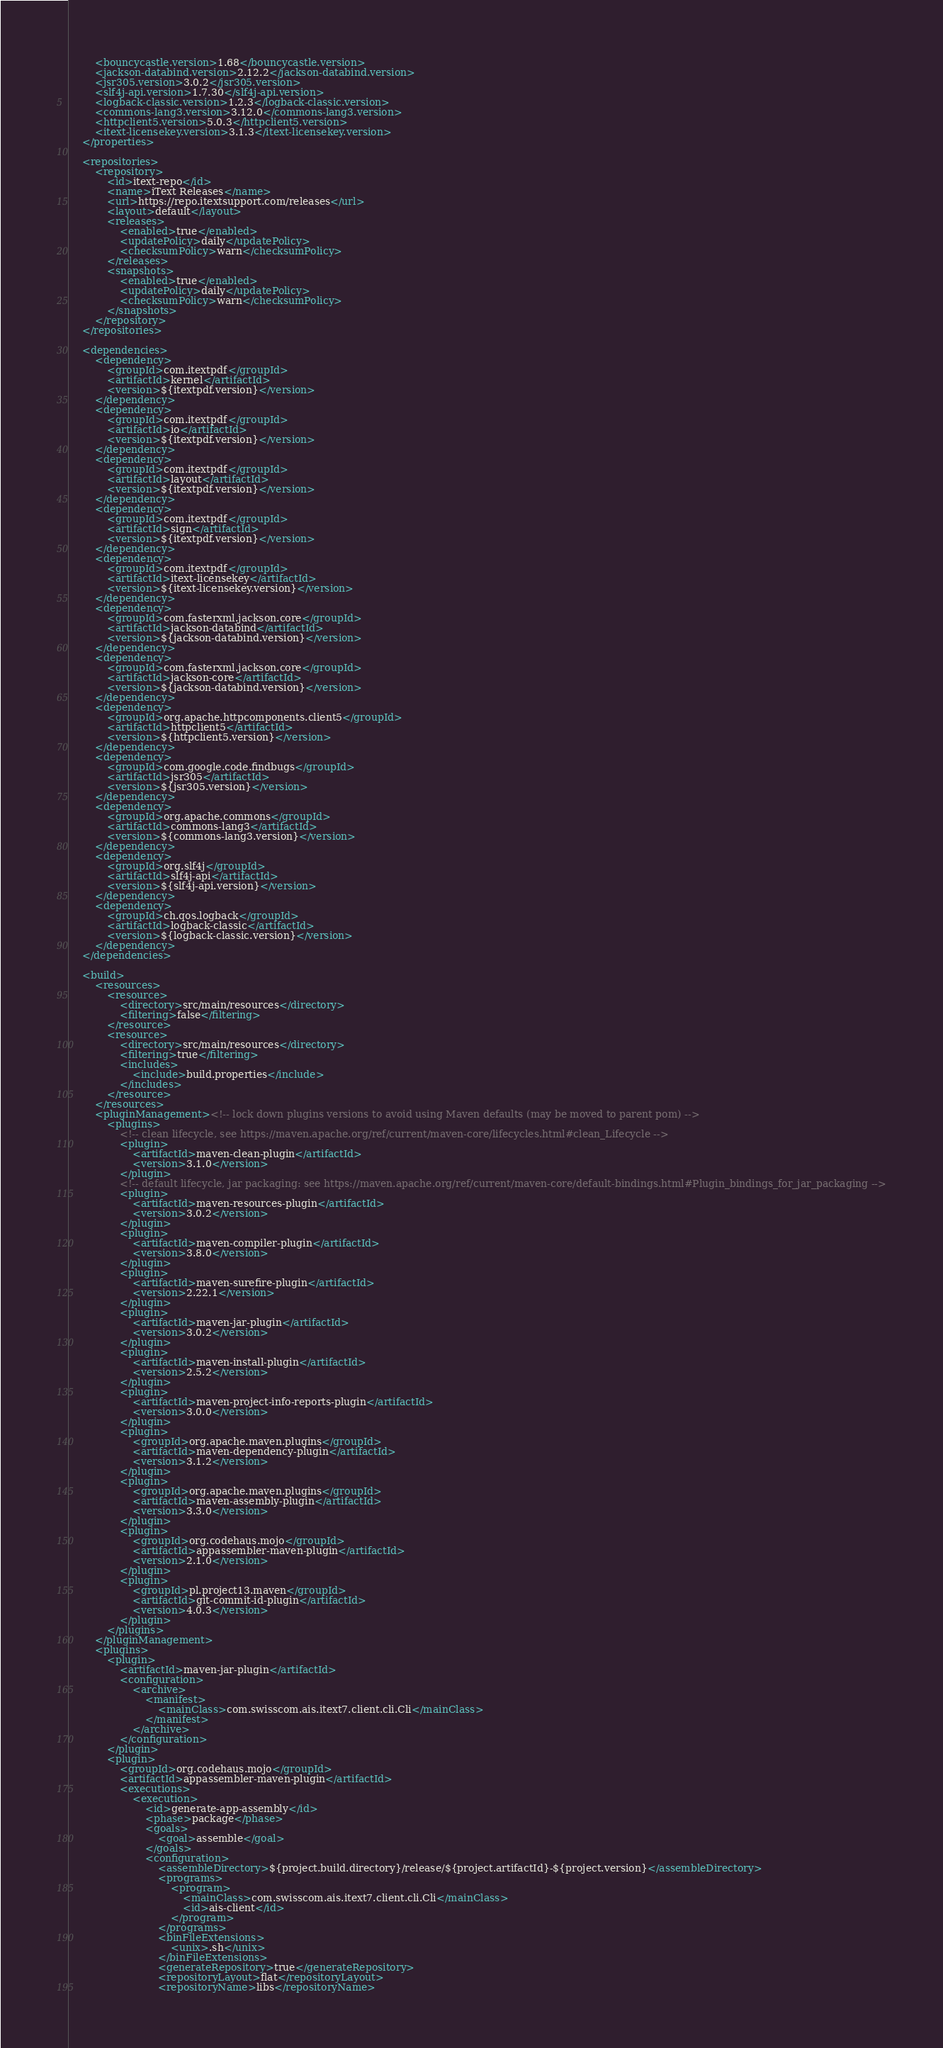<code> <loc_0><loc_0><loc_500><loc_500><_XML_>        <bouncycastle.version>1.68</bouncycastle.version>
        <jackson-databind.version>2.12.2</jackson-databind.version>
        <jsr305.version>3.0.2</jsr305.version>
        <slf4j-api.version>1.7.30</slf4j-api.version>
        <logback-classic.version>1.2.3</logback-classic.version>
        <commons-lang3.version>3.12.0</commons-lang3.version>
        <httpclient5.version>5.0.3</httpclient5.version>
        <itext-licensekey.version>3.1.3</itext-licensekey.version>
    </properties>

    <repositories>
        <repository>
            <id>itext-repo</id>
            <name>iText Releases</name>
            <url>https://repo.itextsupport.com/releases</url>
            <layout>default</layout>
            <releases>
                <enabled>true</enabled>
                <updatePolicy>daily</updatePolicy>
                <checksumPolicy>warn</checksumPolicy>
            </releases>
            <snapshots>
                <enabled>true</enabled>
                <updatePolicy>daily</updatePolicy>
                <checksumPolicy>warn</checksumPolicy>
            </snapshots>
        </repository>
    </repositories>

    <dependencies>
        <dependency>
            <groupId>com.itextpdf</groupId>
            <artifactId>kernel</artifactId>
            <version>${itextpdf.version}</version>
        </dependency>
        <dependency>
            <groupId>com.itextpdf</groupId>
            <artifactId>io</artifactId>
            <version>${itextpdf.version}</version>
        </dependency>
        <dependency>
            <groupId>com.itextpdf</groupId>
            <artifactId>layout</artifactId>
            <version>${itextpdf.version}</version>
        </dependency>
        <dependency>
            <groupId>com.itextpdf</groupId>
            <artifactId>sign</artifactId>
            <version>${itextpdf.version}</version>
        </dependency>
        <dependency>
            <groupId>com.itextpdf</groupId>
            <artifactId>itext-licensekey</artifactId>
            <version>${itext-licensekey.version}</version>
        </dependency>
        <dependency>
            <groupId>com.fasterxml.jackson.core</groupId>
            <artifactId>jackson-databind</artifactId>
            <version>${jackson-databind.version}</version>
        </dependency>
        <dependency>
            <groupId>com.fasterxml.jackson.core</groupId>
            <artifactId>jackson-core</artifactId>
            <version>${jackson-databind.version}</version>
        </dependency>
        <dependency>
            <groupId>org.apache.httpcomponents.client5</groupId>
            <artifactId>httpclient5</artifactId>
            <version>${httpclient5.version}</version>
        </dependency>
        <dependency>
            <groupId>com.google.code.findbugs</groupId>
            <artifactId>jsr305</artifactId>
            <version>${jsr305.version}</version>
        </dependency>
        <dependency>
            <groupId>org.apache.commons</groupId>
            <artifactId>commons-lang3</artifactId>
            <version>${commons-lang3.version}</version>
        </dependency>
        <dependency>
            <groupId>org.slf4j</groupId>
            <artifactId>slf4j-api</artifactId>
            <version>${slf4j-api.version}</version>
        </dependency>
        <dependency>
            <groupId>ch.qos.logback</groupId>
            <artifactId>logback-classic</artifactId>
            <version>${logback-classic.version}</version>
        </dependency>
    </dependencies>

    <build>
        <resources>
            <resource>
                <directory>src/main/resources</directory>
                <filtering>false</filtering>
            </resource>
            <resource>
                <directory>src/main/resources</directory>
                <filtering>true</filtering>
                <includes>
                    <include>build.properties</include>
                </includes>
            </resource>
        </resources>
        <pluginManagement><!-- lock down plugins versions to avoid using Maven defaults (may be moved to parent pom) -->
            <plugins>
                <!-- clean lifecycle, see https://maven.apache.org/ref/current/maven-core/lifecycles.html#clean_Lifecycle -->
                <plugin>
                    <artifactId>maven-clean-plugin</artifactId>
                    <version>3.1.0</version>
                </plugin>
                <!-- default lifecycle, jar packaging: see https://maven.apache.org/ref/current/maven-core/default-bindings.html#Plugin_bindings_for_jar_packaging -->
                <plugin>
                    <artifactId>maven-resources-plugin</artifactId>
                    <version>3.0.2</version>
                </plugin>
                <plugin>
                    <artifactId>maven-compiler-plugin</artifactId>
                    <version>3.8.0</version>
                </plugin>
                <plugin>
                    <artifactId>maven-surefire-plugin</artifactId>
                    <version>2.22.1</version>
                </plugin>
                <plugin>
                    <artifactId>maven-jar-plugin</artifactId>
                    <version>3.0.2</version>
                </plugin>
                <plugin>
                    <artifactId>maven-install-plugin</artifactId>
                    <version>2.5.2</version>
                </plugin>
                <plugin>
                    <artifactId>maven-project-info-reports-plugin</artifactId>
                    <version>3.0.0</version>
                </plugin>
                <plugin>
                    <groupId>org.apache.maven.plugins</groupId>
                    <artifactId>maven-dependency-plugin</artifactId>
                    <version>3.1.2</version>
                </plugin>
                <plugin>
                    <groupId>org.apache.maven.plugins</groupId>
                    <artifactId>maven-assembly-plugin</artifactId>
                    <version>3.3.0</version>
                </plugin>
                <plugin>
                    <groupId>org.codehaus.mojo</groupId>
                    <artifactId>appassembler-maven-plugin</artifactId>
                    <version>2.1.0</version>
                </plugin>
                <plugin>
                    <groupId>pl.project13.maven</groupId>
                    <artifactId>git-commit-id-plugin</artifactId>
                    <version>4.0.3</version>
                </plugin>
            </plugins>
        </pluginManagement>
        <plugins>
            <plugin>
                <artifactId>maven-jar-plugin</artifactId>
                <configuration>
                    <archive>
                        <manifest>
                            <mainClass>com.swisscom.ais.itext7.client.cli.Cli</mainClass>
                        </manifest>
                    </archive>
                </configuration>
            </plugin>
            <plugin>
                <groupId>org.codehaus.mojo</groupId>
                <artifactId>appassembler-maven-plugin</artifactId>
                <executions>
                    <execution>
                        <id>generate-app-assembly</id>
                        <phase>package</phase>
                        <goals>
                            <goal>assemble</goal>
                        </goals>
                        <configuration>
                            <assembleDirectory>${project.build.directory}/release/${project.artifactId}-${project.version}</assembleDirectory>
                            <programs>
                                <program>
                                    <mainClass>com.swisscom.ais.itext7.client.cli.Cli</mainClass>
                                    <id>ais-client</id>
                                </program>
                            </programs>
                            <binFileExtensions>
                                <unix>.sh</unix>
                            </binFileExtensions>
                            <generateRepository>true</generateRepository>
                            <repositoryLayout>flat</repositoryLayout>
                            <repositoryName>libs</repositoryName></code> 